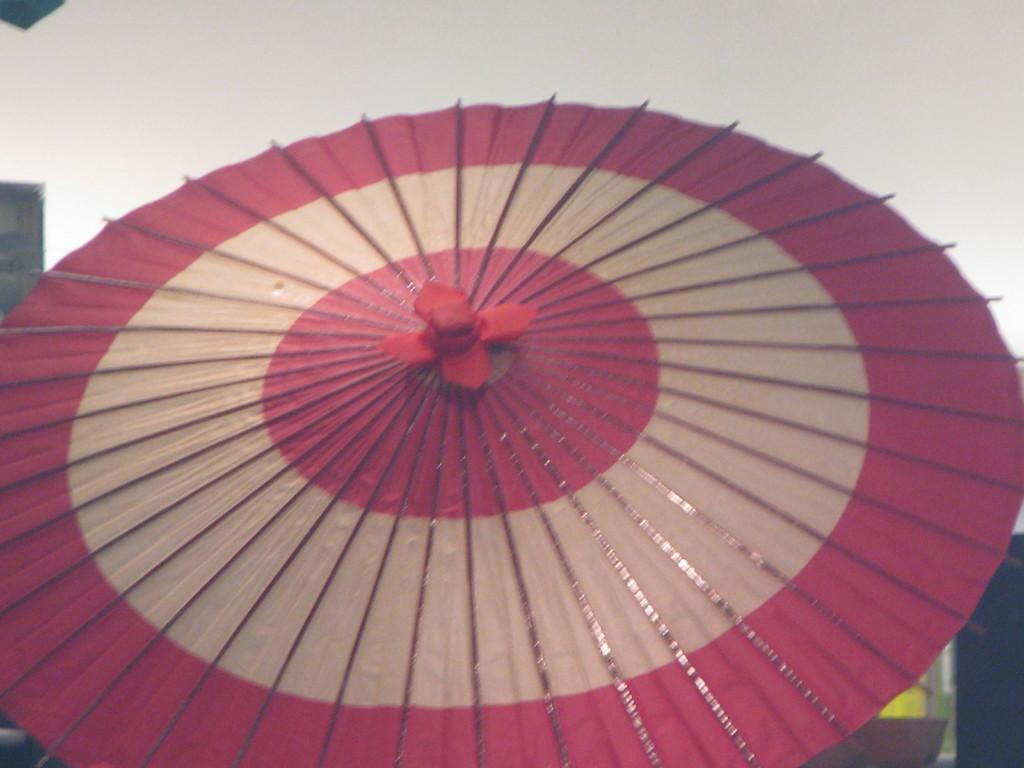What is the main subject of the image? There is an object in the image. What does the object resemble? The object looks like an umbrella. What colors can be seen on the object? The object is in pink and cream colors. Can you tell me how many buttons are on the stranger's shirt in the image? There is no stranger or shirt with buttons present in the image; it features an object that resembles an umbrella in pink and cream colors. Is there a desk visible in the image? There is no desk present in the image; it only features an object that resembles an umbrella in pink and cream colors. 